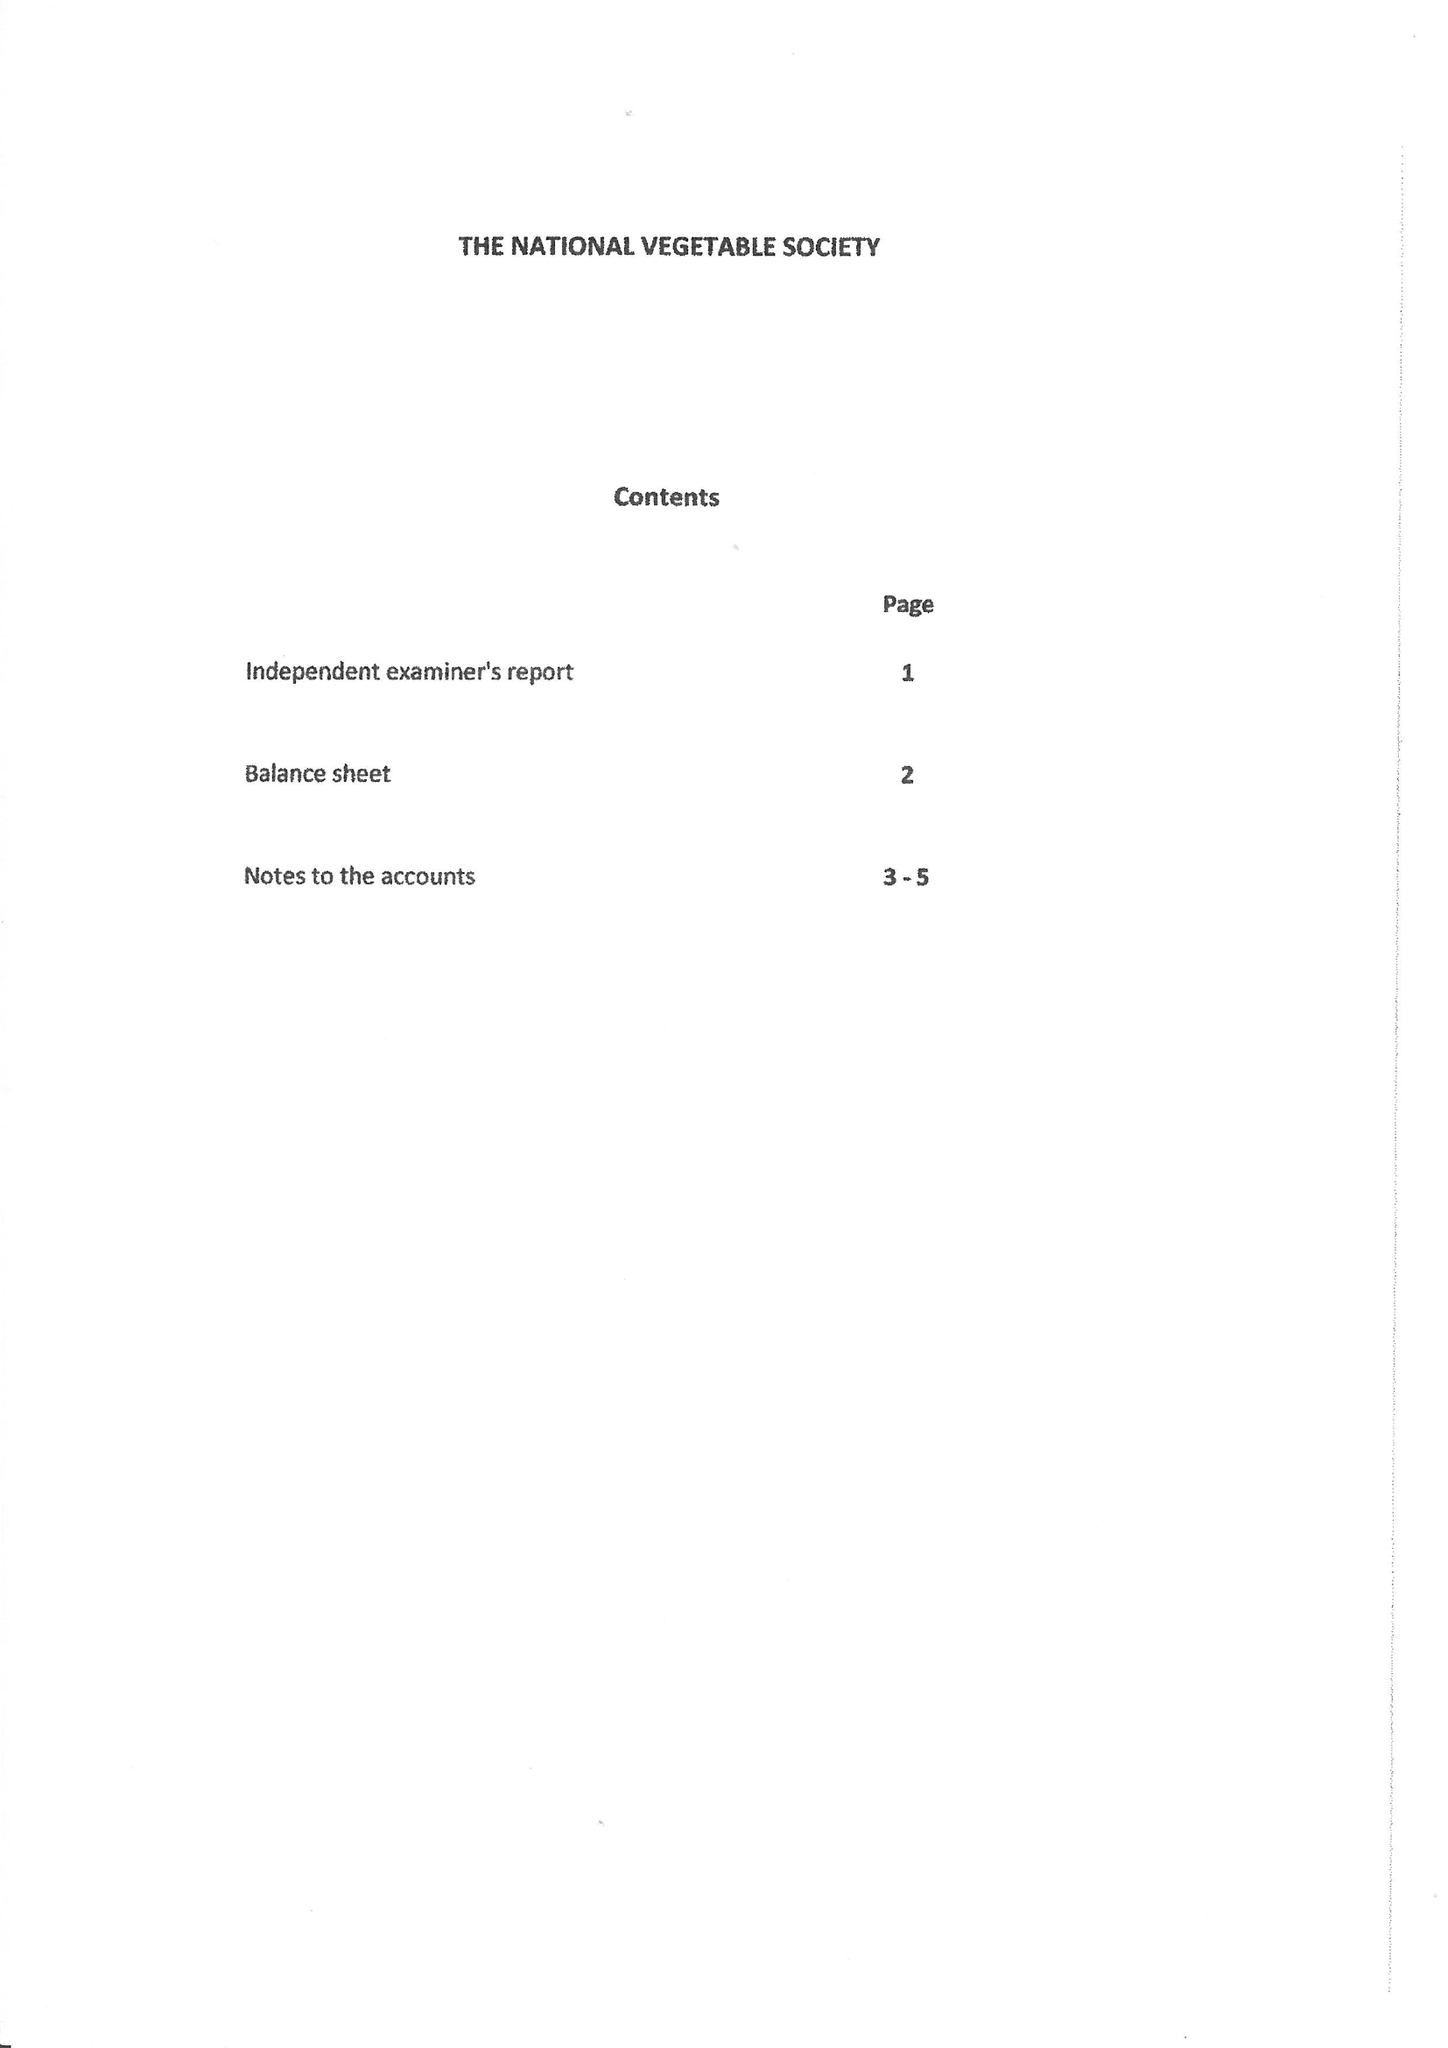What is the value for the address__street_line?
Answer the question using a single word or phrase. 4 CANMORE STREET 